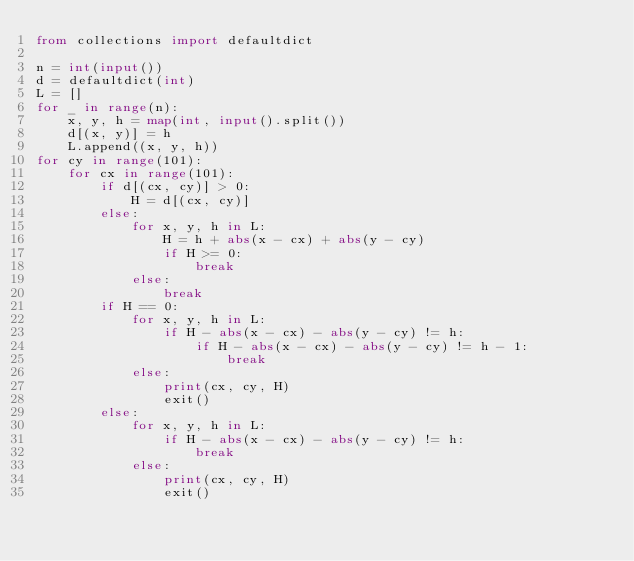<code> <loc_0><loc_0><loc_500><loc_500><_Python_>from collections import defaultdict

n = int(input())
d = defaultdict(int)
L = []
for _ in range(n):
    x, y, h = map(int, input().split())
    d[(x, y)] = h
    L.append((x, y, h))
for cy in range(101):
    for cx in range(101):
        if d[(cx, cy)] > 0:
            H = d[(cx, cy)]
        else:
            for x, y, h in L:
                H = h + abs(x - cx) + abs(y - cy)
                if H >= 0:
                    break
            else:
                break
        if H == 0:
            for x, y, h in L:
                if H - abs(x - cx) - abs(y - cy) != h:
                    if H - abs(x - cx) - abs(y - cy) != h - 1:
                        break
            else:
                print(cx, cy, H)
                exit()
        else:
            for x, y, h in L:
                if H - abs(x - cx) - abs(y - cy) != h:
                    break
            else:
                print(cx, cy, H)
                exit()
</code> 